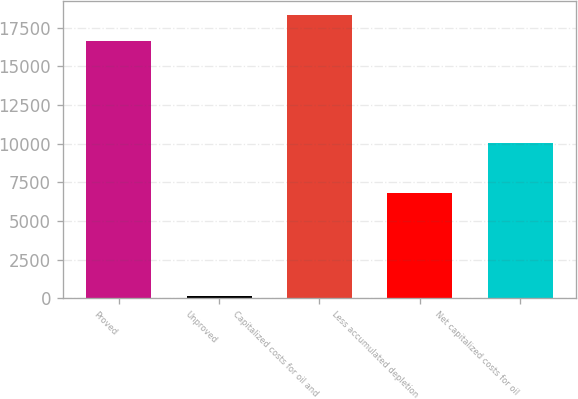<chart> <loc_0><loc_0><loc_500><loc_500><bar_chart><fcel>Proved<fcel>Unproved<fcel>Capitalized costs for oil and<fcel>Less accumulated depletion<fcel>Net capitalized costs for oil<nl><fcel>16631<fcel>169<fcel>18294.1<fcel>6778<fcel>10022<nl></chart> 